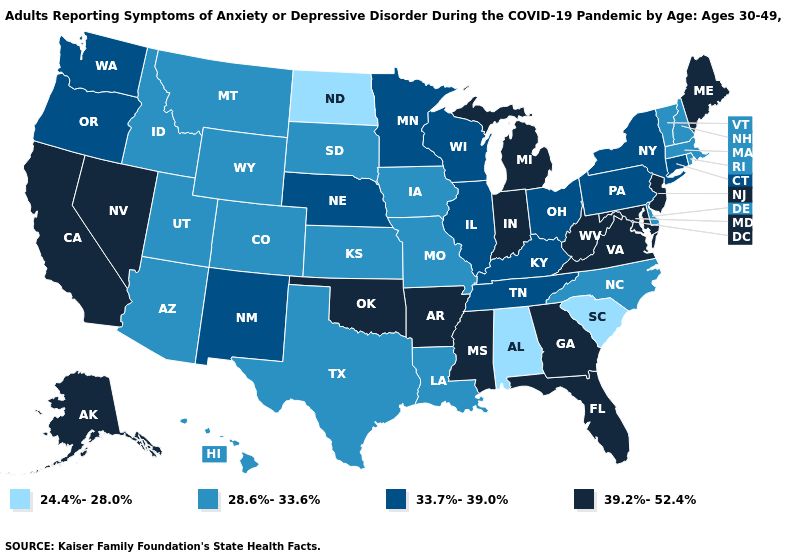Name the states that have a value in the range 24.4%-28.0%?
Keep it brief. Alabama, North Dakota, South Carolina. Does Kansas have the highest value in the USA?
Quick response, please. No. What is the highest value in the USA?
Short answer required. 39.2%-52.4%. Among the states that border Texas , which have the highest value?
Write a very short answer. Arkansas, Oklahoma. Name the states that have a value in the range 24.4%-28.0%?
Be succinct. Alabama, North Dakota, South Carolina. What is the lowest value in states that border South Carolina?
Quick response, please. 28.6%-33.6%. Does Virginia have a higher value than Rhode Island?
Keep it brief. Yes. Name the states that have a value in the range 33.7%-39.0%?
Write a very short answer. Connecticut, Illinois, Kentucky, Minnesota, Nebraska, New Mexico, New York, Ohio, Oregon, Pennsylvania, Tennessee, Washington, Wisconsin. What is the value of Iowa?
Short answer required. 28.6%-33.6%. What is the lowest value in the USA?
Quick response, please. 24.4%-28.0%. What is the value of Georgia?
Keep it brief. 39.2%-52.4%. What is the value of Washington?
Keep it brief. 33.7%-39.0%. What is the value of New Hampshire?
Keep it brief. 28.6%-33.6%. What is the value of North Dakota?
Be succinct. 24.4%-28.0%. Name the states that have a value in the range 24.4%-28.0%?
Quick response, please. Alabama, North Dakota, South Carolina. 